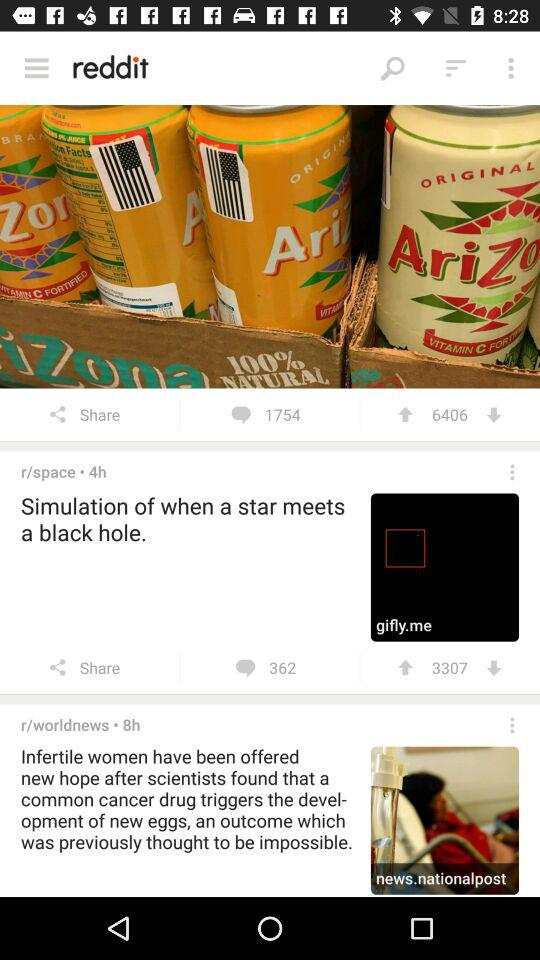How many comments are there for the post with 6406 votes? There are 1754 comments. 